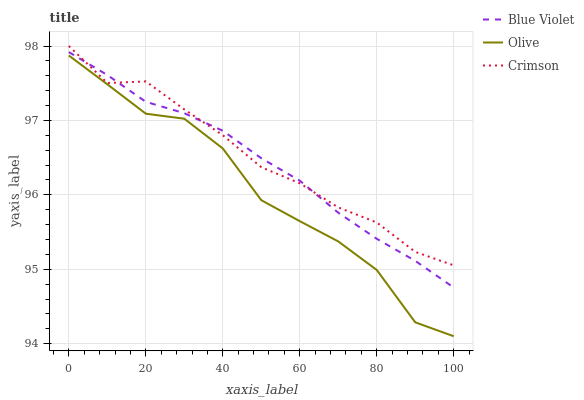Does Olive have the minimum area under the curve?
Answer yes or no. Yes. Does Crimson have the maximum area under the curve?
Answer yes or no. Yes. Does Blue Violet have the minimum area under the curve?
Answer yes or no. No. Does Blue Violet have the maximum area under the curve?
Answer yes or no. No. Is Blue Violet the smoothest?
Answer yes or no. Yes. Is Olive the roughest?
Answer yes or no. Yes. Is Crimson the smoothest?
Answer yes or no. No. Is Crimson the roughest?
Answer yes or no. No. Does Olive have the lowest value?
Answer yes or no. Yes. Does Blue Violet have the lowest value?
Answer yes or no. No. Does Crimson have the highest value?
Answer yes or no. Yes. Does Blue Violet have the highest value?
Answer yes or no. No. Is Olive less than Crimson?
Answer yes or no. Yes. Is Crimson greater than Olive?
Answer yes or no. Yes. Does Blue Violet intersect Crimson?
Answer yes or no. Yes. Is Blue Violet less than Crimson?
Answer yes or no. No. Is Blue Violet greater than Crimson?
Answer yes or no. No. Does Olive intersect Crimson?
Answer yes or no. No. 